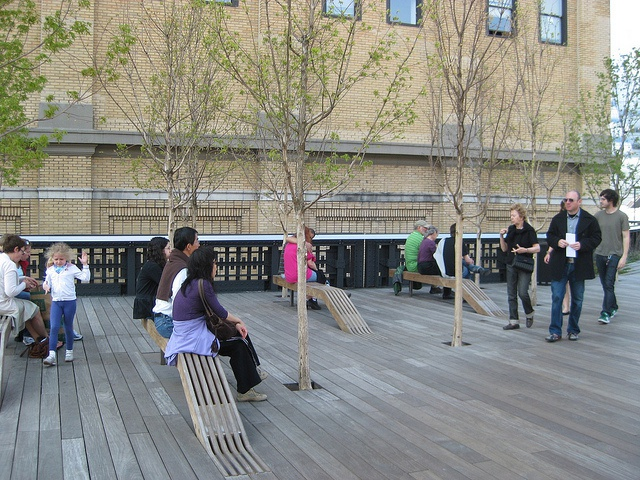Describe the objects in this image and their specific colors. I can see people in darkgreen, black, gray, lightblue, and darkgray tones, people in darkgreen, black, navy, darkgray, and blue tones, bench in darkgreen, darkgray, gray, and black tones, people in darkgreen, lavender, navy, gray, and darkgray tones, and people in darkgreen, black, gray, darkblue, and darkgray tones in this image. 